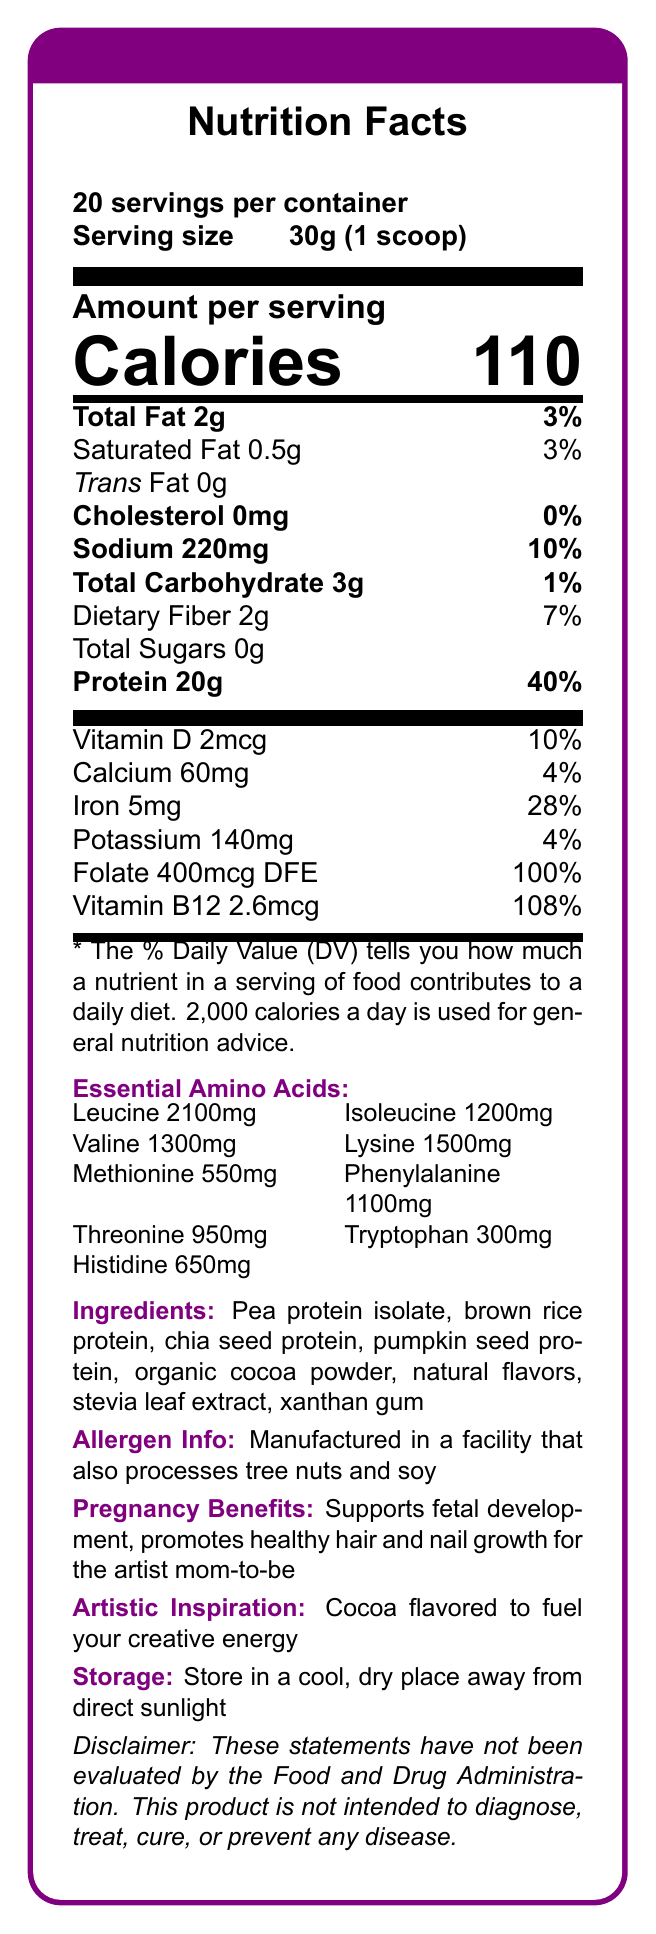What is the serving size of ArtistMom Bloom Protein? The serving size is stated clearly as "30g (1 scoop)" in the document.
Answer: 30g (1 scoop) How many calories are in one serving of ArtistMom Bloom Protein? The document states "Calories 110" under the nutrition facts.
Answer: 110 What percentage of the daily value of protein does one serving provide? The protein daily value percentage is specified as "40%" next to "Protein 20g".
Answer: 40% Which ingredient provides the primary protein source? The first ingredient listed in the ingredients section is "Pea protein isolate," indicating it is the primary source.
Answer: Pea protein isolate Which amino acid has the highest content per serving? The document lists essential amino acids, and Leucine has the highest content at "2100mg".
Answer: Leucine How many servings are there per container? A. 15 B. 20 C. 25 D. 30 The document notes "20 servings per container" at the top.
Answer: B. 20 Which nutrient contributes the least to the daily value percentage? A. Calcium B. Vitamin D C. Iron D. Potassium Calcium contributes "4%" to the daily value, whereas Vitamin D, Iron, and Potassium contribute more.
Answer: A. Calcium Does the product contain any cholesterol? The document states "Cholesterol 0mg" indicating there is no cholesterol in the product.
Answer: No Can ArtistMom Bloom Protein help with fetal development? The pregnancy benefits section states it "Supports fetal development."
Answer: Yes Summarize the main purpose of ArtistMom Bloom Protein. The document emphasizes that ArtistMom Bloom Protein is specifically formulated for pregnant artists, highlighting its nutritional benefits, essential amino acids, and artistic inspiration.
Answer: ArtistMom Bloom Protein is a plant-based protein powder designed to support pregnant artists by providing essential nutrients and amino acids, promoting healthy hair, nail growth, and fetal development, and fueling creative energy. What is the protein content of methionine per serving? The essential amino acids section lists Methionine as "550mg".
Answer: 550mg Which of the following allergens may be present due to manufacturing? A. Gluten B. Tree nuts C. Dairy D. Shellfish The allergen information mentions it is manufactured in a facility that processes "tree nuts and soy."
Answer: B. Tree nuts What is the daily value percentage for sodium? The document clearly states "Sodium 220mg" with "10%" of the daily value.
Answer: 10% Is there any artificial sweetener listed in the ingredients? The sweetener listed is "stevia leaf extract," which is a natural sweetener.
Answer: No Can using this product guarantee improved fetal development and hair growth? The disclaimer at the bottom states, "These statements have not been evaluated by the Food and Drug Administration," indicating no guarantees.
Answer: Cannot be determined 